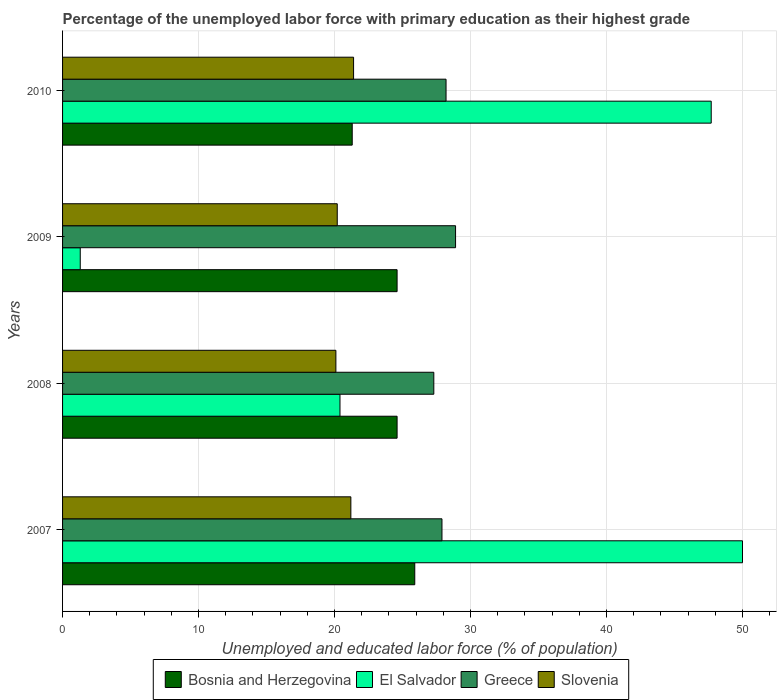How many different coloured bars are there?
Provide a succinct answer. 4. How many groups of bars are there?
Make the answer very short. 4. How many bars are there on the 4th tick from the bottom?
Provide a short and direct response. 4. In how many cases, is the number of bars for a given year not equal to the number of legend labels?
Keep it short and to the point. 0. What is the percentage of the unemployed labor force with primary education in Bosnia and Herzegovina in 2009?
Ensure brevity in your answer.  24.6. Across all years, what is the maximum percentage of the unemployed labor force with primary education in Greece?
Provide a short and direct response. 28.9. Across all years, what is the minimum percentage of the unemployed labor force with primary education in Bosnia and Herzegovina?
Your answer should be very brief. 21.3. In which year was the percentage of the unemployed labor force with primary education in Slovenia maximum?
Keep it short and to the point. 2010. In which year was the percentage of the unemployed labor force with primary education in El Salvador minimum?
Provide a short and direct response. 2009. What is the total percentage of the unemployed labor force with primary education in El Salvador in the graph?
Ensure brevity in your answer.  119.4. What is the difference between the percentage of the unemployed labor force with primary education in Greece in 2007 and that in 2010?
Provide a short and direct response. -0.3. What is the difference between the percentage of the unemployed labor force with primary education in El Salvador in 2010 and the percentage of the unemployed labor force with primary education in Slovenia in 2009?
Offer a very short reply. 27.5. What is the average percentage of the unemployed labor force with primary education in Bosnia and Herzegovina per year?
Offer a terse response. 24.1. In the year 2010, what is the difference between the percentage of the unemployed labor force with primary education in El Salvador and percentage of the unemployed labor force with primary education in Greece?
Keep it short and to the point. 19.5. What is the ratio of the percentage of the unemployed labor force with primary education in Greece in 2008 to that in 2009?
Ensure brevity in your answer.  0.94. Is the percentage of the unemployed labor force with primary education in Slovenia in 2007 less than that in 2008?
Make the answer very short. No. Is the difference between the percentage of the unemployed labor force with primary education in El Salvador in 2007 and 2008 greater than the difference between the percentage of the unemployed labor force with primary education in Greece in 2007 and 2008?
Your response must be concise. Yes. What is the difference between the highest and the second highest percentage of the unemployed labor force with primary education in Bosnia and Herzegovina?
Your answer should be very brief. 1.3. What is the difference between the highest and the lowest percentage of the unemployed labor force with primary education in Slovenia?
Offer a terse response. 1.3. Is the sum of the percentage of the unemployed labor force with primary education in Bosnia and Herzegovina in 2007 and 2008 greater than the maximum percentage of the unemployed labor force with primary education in Greece across all years?
Keep it short and to the point. Yes. Is it the case that in every year, the sum of the percentage of the unemployed labor force with primary education in Greece and percentage of the unemployed labor force with primary education in El Salvador is greater than the sum of percentage of the unemployed labor force with primary education in Bosnia and Herzegovina and percentage of the unemployed labor force with primary education in Slovenia?
Offer a terse response. No. What does the 3rd bar from the top in 2007 represents?
Make the answer very short. El Salvador. What does the 2nd bar from the bottom in 2008 represents?
Keep it short and to the point. El Salvador. Are all the bars in the graph horizontal?
Provide a short and direct response. Yes. How many years are there in the graph?
Your response must be concise. 4. Are the values on the major ticks of X-axis written in scientific E-notation?
Offer a very short reply. No. Does the graph contain grids?
Provide a succinct answer. Yes. Where does the legend appear in the graph?
Offer a very short reply. Bottom center. How many legend labels are there?
Ensure brevity in your answer.  4. How are the legend labels stacked?
Offer a very short reply. Horizontal. What is the title of the graph?
Offer a very short reply. Percentage of the unemployed labor force with primary education as their highest grade. Does "Nigeria" appear as one of the legend labels in the graph?
Your answer should be very brief. No. What is the label or title of the X-axis?
Offer a very short reply. Unemployed and educated labor force (% of population). What is the Unemployed and educated labor force (% of population) in Bosnia and Herzegovina in 2007?
Ensure brevity in your answer.  25.9. What is the Unemployed and educated labor force (% of population) in El Salvador in 2007?
Offer a terse response. 50. What is the Unemployed and educated labor force (% of population) in Greece in 2007?
Give a very brief answer. 27.9. What is the Unemployed and educated labor force (% of population) of Slovenia in 2007?
Keep it short and to the point. 21.2. What is the Unemployed and educated labor force (% of population) in Bosnia and Herzegovina in 2008?
Make the answer very short. 24.6. What is the Unemployed and educated labor force (% of population) of El Salvador in 2008?
Provide a short and direct response. 20.4. What is the Unemployed and educated labor force (% of population) in Greece in 2008?
Offer a very short reply. 27.3. What is the Unemployed and educated labor force (% of population) in Slovenia in 2008?
Give a very brief answer. 20.1. What is the Unemployed and educated labor force (% of population) in Bosnia and Herzegovina in 2009?
Provide a succinct answer. 24.6. What is the Unemployed and educated labor force (% of population) in El Salvador in 2009?
Give a very brief answer. 1.3. What is the Unemployed and educated labor force (% of population) in Greece in 2009?
Make the answer very short. 28.9. What is the Unemployed and educated labor force (% of population) of Slovenia in 2009?
Make the answer very short. 20.2. What is the Unemployed and educated labor force (% of population) in Bosnia and Herzegovina in 2010?
Make the answer very short. 21.3. What is the Unemployed and educated labor force (% of population) of El Salvador in 2010?
Give a very brief answer. 47.7. What is the Unemployed and educated labor force (% of population) in Greece in 2010?
Offer a very short reply. 28.2. What is the Unemployed and educated labor force (% of population) of Slovenia in 2010?
Your response must be concise. 21.4. Across all years, what is the maximum Unemployed and educated labor force (% of population) of Bosnia and Herzegovina?
Your answer should be compact. 25.9. Across all years, what is the maximum Unemployed and educated labor force (% of population) of El Salvador?
Provide a succinct answer. 50. Across all years, what is the maximum Unemployed and educated labor force (% of population) of Greece?
Your answer should be very brief. 28.9. Across all years, what is the maximum Unemployed and educated labor force (% of population) in Slovenia?
Your answer should be very brief. 21.4. Across all years, what is the minimum Unemployed and educated labor force (% of population) in Bosnia and Herzegovina?
Offer a terse response. 21.3. Across all years, what is the minimum Unemployed and educated labor force (% of population) of El Salvador?
Make the answer very short. 1.3. Across all years, what is the minimum Unemployed and educated labor force (% of population) in Greece?
Ensure brevity in your answer.  27.3. Across all years, what is the minimum Unemployed and educated labor force (% of population) in Slovenia?
Keep it short and to the point. 20.1. What is the total Unemployed and educated labor force (% of population) in Bosnia and Herzegovina in the graph?
Provide a short and direct response. 96.4. What is the total Unemployed and educated labor force (% of population) in El Salvador in the graph?
Ensure brevity in your answer.  119.4. What is the total Unemployed and educated labor force (% of population) in Greece in the graph?
Offer a very short reply. 112.3. What is the total Unemployed and educated labor force (% of population) in Slovenia in the graph?
Offer a terse response. 82.9. What is the difference between the Unemployed and educated labor force (% of population) of Bosnia and Herzegovina in 2007 and that in 2008?
Provide a short and direct response. 1.3. What is the difference between the Unemployed and educated labor force (% of population) of El Salvador in 2007 and that in 2008?
Your answer should be very brief. 29.6. What is the difference between the Unemployed and educated labor force (% of population) in Slovenia in 2007 and that in 2008?
Your response must be concise. 1.1. What is the difference between the Unemployed and educated labor force (% of population) in El Salvador in 2007 and that in 2009?
Make the answer very short. 48.7. What is the difference between the Unemployed and educated labor force (% of population) in Greece in 2007 and that in 2010?
Your response must be concise. -0.3. What is the difference between the Unemployed and educated labor force (% of population) in Slovenia in 2007 and that in 2010?
Your answer should be very brief. -0.2. What is the difference between the Unemployed and educated labor force (% of population) of Bosnia and Herzegovina in 2008 and that in 2009?
Provide a succinct answer. 0. What is the difference between the Unemployed and educated labor force (% of population) of Bosnia and Herzegovina in 2008 and that in 2010?
Offer a terse response. 3.3. What is the difference between the Unemployed and educated labor force (% of population) in El Salvador in 2008 and that in 2010?
Keep it short and to the point. -27.3. What is the difference between the Unemployed and educated labor force (% of population) of Greece in 2008 and that in 2010?
Your response must be concise. -0.9. What is the difference between the Unemployed and educated labor force (% of population) of Bosnia and Herzegovina in 2009 and that in 2010?
Your answer should be compact. 3.3. What is the difference between the Unemployed and educated labor force (% of population) in El Salvador in 2009 and that in 2010?
Your response must be concise. -46.4. What is the difference between the Unemployed and educated labor force (% of population) of Bosnia and Herzegovina in 2007 and the Unemployed and educated labor force (% of population) of Greece in 2008?
Provide a succinct answer. -1.4. What is the difference between the Unemployed and educated labor force (% of population) of Bosnia and Herzegovina in 2007 and the Unemployed and educated labor force (% of population) of Slovenia in 2008?
Make the answer very short. 5.8. What is the difference between the Unemployed and educated labor force (% of population) in El Salvador in 2007 and the Unemployed and educated labor force (% of population) in Greece in 2008?
Give a very brief answer. 22.7. What is the difference between the Unemployed and educated labor force (% of population) in El Salvador in 2007 and the Unemployed and educated labor force (% of population) in Slovenia in 2008?
Your answer should be very brief. 29.9. What is the difference between the Unemployed and educated labor force (% of population) in Bosnia and Herzegovina in 2007 and the Unemployed and educated labor force (% of population) in El Salvador in 2009?
Provide a succinct answer. 24.6. What is the difference between the Unemployed and educated labor force (% of population) of Bosnia and Herzegovina in 2007 and the Unemployed and educated labor force (% of population) of Slovenia in 2009?
Make the answer very short. 5.7. What is the difference between the Unemployed and educated labor force (% of population) of El Salvador in 2007 and the Unemployed and educated labor force (% of population) of Greece in 2009?
Your answer should be very brief. 21.1. What is the difference between the Unemployed and educated labor force (% of population) in El Salvador in 2007 and the Unemployed and educated labor force (% of population) in Slovenia in 2009?
Your answer should be compact. 29.8. What is the difference between the Unemployed and educated labor force (% of population) of Bosnia and Herzegovina in 2007 and the Unemployed and educated labor force (% of population) of El Salvador in 2010?
Provide a succinct answer. -21.8. What is the difference between the Unemployed and educated labor force (% of population) of El Salvador in 2007 and the Unemployed and educated labor force (% of population) of Greece in 2010?
Your answer should be compact. 21.8. What is the difference between the Unemployed and educated labor force (% of population) in El Salvador in 2007 and the Unemployed and educated labor force (% of population) in Slovenia in 2010?
Provide a short and direct response. 28.6. What is the difference between the Unemployed and educated labor force (% of population) of Bosnia and Herzegovina in 2008 and the Unemployed and educated labor force (% of population) of El Salvador in 2009?
Offer a terse response. 23.3. What is the difference between the Unemployed and educated labor force (% of population) of Bosnia and Herzegovina in 2008 and the Unemployed and educated labor force (% of population) of Slovenia in 2009?
Provide a succinct answer. 4.4. What is the difference between the Unemployed and educated labor force (% of population) of El Salvador in 2008 and the Unemployed and educated labor force (% of population) of Slovenia in 2009?
Provide a succinct answer. 0.2. What is the difference between the Unemployed and educated labor force (% of population) in Greece in 2008 and the Unemployed and educated labor force (% of population) in Slovenia in 2009?
Ensure brevity in your answer.  7.1. What is the difference between the Unemployed and educated labor force (% of population) of Bosnia and Herzegovina in 2008 and the Unemployed and educated labor force (% of population) of El Salvador in 2010?
Your response must be concise. -23.1. What is the difference between the Unemployed and educated labor force (% of population) in Bosnia and Herzegovina in 2008 and the Unemployed and educated labor force (% of population) in Slovenia in 2010?
Ensure brevity in your answer.  3.2. What is the difference between the Unemployed and educated labor force (% of population) of Greece in 2008 and the Unemployed and educated labor force (% of population) of Slovenia in 2010?
Ensure brevity in your answer.  5.9. What is the difference between the Unemployed and educated labor force (% of population) of Bosnia and Herzegovina in 2009 and the Unemployed and educated labor force (% of population) of El Salvador in 2010?
Give a very brief answer. -23.1. What is the difference between the Unemployed and educated labor force (% of population) in Bosnia and Herzegovina in 2009 and the Unemployed and educated labor force (% of population) in Greece in 2010?
Offer a very short reply. -3.6. What is the difference between the Unemployed and educated labor force (% of population) of El Salvador in 2009 and the Unemployed and educated labor force (% of population) of Greece in 2010?
Your response must be concise. -26.9. What is the difference between the Unemployed and educated labor force (% of population) of El Salvador in 2009 and the Unemployed and educated labor force (% of population) of Slovenia in 2010?
Offer a very short reply. -20.1. What is the difference between the Unemployed and educated labor force (% of population) in Greece in 2009 and the Unemployed and educated labor force (% of population) in Slovenia in 2010?
Ensure brevity in your answer.  7.5. What is the average Unemployed and educated labor force (% of population) in Bosnia and Herzegovina per year?
Offer a very short reply. 24.1. What is the average Unemployed and educated labor force (% of population) of El Salvador per year?
Your answer should be compact. 29.85. What is the average Unemployed and educated labor force (% of population) in Greece per year?
Ensure brevity in your answer.  28.07. What is the average Unemployed and educated labor force (% of population) in Slovenia per year?
Give a very brief answer. 20.73. In the year 2007, what is the difference between the Unemployed and educated labor force (% of population) of Bosnia and Herzegovina and Unemployed and educated labor force (% of population) of El Salvador?
Provide a succinct answer. -24.1. In the year 2007, what is the difference between the Unemployed and educated labor force (% of population) in Bosnia and Herzegovina and Unemployed and educated labor force (% of population) in Greece?
Keep it short and to the point. -2. In the year 2007, what is the difference between the Unemployed and educated labor force (% of population) of Bosnia and Herzegovina and Unemployed and educated labor force (% of population) of Slovenia?
Your answer should be very brief. 4.7. In the year 2007, what is the difference between the Unemployed and educated labor force (% of population) of El Salvador and Unemployed and educated labor force (% of population) of Greece?
Your response must be concise. 22.1. In the year 2007, what is the difference between the Unemployed and educated labor force (% of population) in El Salvador and Unemployed and educated labor force (% of population) in Slovenia?
Provide a short and direct response. 28.8. In the year 2008, what is the difference between the Unemployed and educated labor force (% of population) in Bosnia and Herzegovina and Unemployed and educated labor force (% of population) in El Salvador?
Offer a terse response. 4.2. In the year 2008, what is the difference between the Unemployed and educated labor force (% of population) in Bosnia and Herzegovina and Unemployed and educated labor force (% of population) in Greece?
Your answer should be compact. -2.7. In the year 2008, what is the difference between the Unemployed and educated labor force (% of population) in El Salvador and Unemployed and educated labor force (% of population) in Greece?
Your response must be concise. -6.9. In the year 2009, what is the difference between the Unemployed and educated labor force (% of population) in Bosnia and Herzegovina and Unemployed and educated labor force (% of population) in El Salvador?
Provide a short and direct response. 23.3. In the year 2009, what is the difference between the Unemployed and educated labor force (% of population) in El Salvador and Unemployed and educated labor force (% of population) in Greece?
Give a very brief answer. -27.6. In the year 2009, what is the difference between the Unemployed and educated labor force (% of population) in El Salvador and Unemployed and educated labor force (% of population) in Slovenia?
Ensure brevity in your answer.  -18.9. In the year 2009, what is the difference between the Unemployed and educated labor force (% of population) in Greece and Unemployed and educated labor force (% of population) in Slovenia?
Provide a short and direct response. 8.7. In the year 2010, what is the difference between the Unemployed and educated labor force (% of population) in Bosnia and Herzegovina and Unemployed and educated labor force (% of population) in El Salvador?
Provide a succinct answer. -26.4. In the year 2010, what is the difference between the Unemployed and educated labor force (% of population) in El Salvador and Unemployed and educated labor force (% of population) in Greece?
Offer a terse response. 19.5. In the year 2010, what is the difference between the Unemployed and educated labor force (% of population) in El Salvador and Unemployed and educated labor force (% of population) in Slovenia?
Offer a very short reply. 26.3. In the year 2010, what is the difference between the Unemployed and educated labor force (% of population) in Greece and Unemployed and educated labor force (% of population) in Slovenia?
Keep it short and to the point. 6.8. What is the ratio of the Unemployed and educated labor force (% of population) in Bosnia and Herzegovina in 2007 to that in 2008?
Ensure brevity in your answer.  1.05. What is the ratio of the Unemployed and educated labor force (% of population) of El Salvador in 2007 to that in 2008?
Make the answer very short. 2.45. What is the ratio of the Unemployed and educated labor force (% of population) of Slovenia in 2007 to that in 2008?
Provide a short and direct response. 1.05. What is the ratio of the Unemployed and educated labor force (% of population) in Bosnia and Herzegovina in 2007 to that in 2009?
Provide a succinct answer. 1.05. What is the ratio of the Unemployed and educated labor force (% of population) of El Salvador in 2007 to that in 2009?
Ensure brevity in your answer.  38.46. What is the ratio of the Unemployed and educated labor force (% of population) in Greece in 2007 to that in 2009?
Keep it short and to the point. 0.97. What is the ratio of the Unemployed and educated labor force (% of population) in Slovenia in 2007 to that in 2009?
Your response must be concise. 1.05. What is the ratio of the Unemployed and educated labor force (% of population) of Bosnia and Herzegovina in 2007 to that in 2010?
Keep it short and to the point. 1.22. What is the ratio of the Unemployed and educated labor force (% of population) in El Salvador in 2007 to that in 2010?
Ensure brevity in your answer.  1.05. What is the ratio of the Unemployed and educated labor force (% of population) of Greece in 2007 to that in 2010?
Your answer should be compact. 0.99. What is the ratio of the Unemployed and educated labor force (% of population) in Bosnia and Herzegovina in 2008 to that in 2009?
Provide a succinct answer. 1. What is the ratio of the Unemployed and educated labor force (% of population) in El Salvador in 2008 to that in 2009?
Provide a short and direct response. 15.69. What is the ratio of the Unemployed and educated labor force (% of population) of Greece in 2008 to that in 2009?
Your answer should be very brief. 0.94. What is the ratio of the Unemployed and educated labor force (% of population) of Slovenia in 2008 to that in 2009?
Provide a short and direct response. 0.99. What is the ratio of the Unemployed and educated labor force (% of population) of Bosnia and Herzegovina in 2008 to that in 2010?
Give a very brief answer. 1.15. What is the ratio of the Unemployed and educated labor force (% of population) of El Salvador in 2008 to that in 2010?
Offer a terse response. 0.43. What is the ratio of the Unemployed and educated labor force (% of population) in Greece in 2008 to that in 2010?
Keep it short and to the point. 0.97. What is the ratio of the Unemployed and educated labor force (% of population) in Slovenia in 2008 to that in 2010?
Make the answer very short. 0.94. What is the ratio of the Unemployed and educated labor force (% of population) in Bosnia and Herzegovina in 2009 to that in 2010?
Provide a succinct answer. 1.15. What is the ratio of the Unemployed and educated labor force (% of population) of El Salvador in 2009 to that in 2010?
Offer a very short reply. 0.03. What is the ratio of the Unemployed and educated labor force (% of population) in Greece in 2009 to that in 2010?
Give a very brief answer. 1.02. What is the ratio of the Unemployed and educated labor force (% of population) of Slovenia in 2009 to that in 2010?
Keep it short and to the point. 0.94. What is the difference between the highest and the second highest Unemployed and educated labor force (% of population) in El Salvador?
Your answer should be compact. 2.3. What is the difference between the highest and the lowest Unemployed and educated labor force (% of population) of El Salvador?
Ensure brevity in your answer.  48.7. 